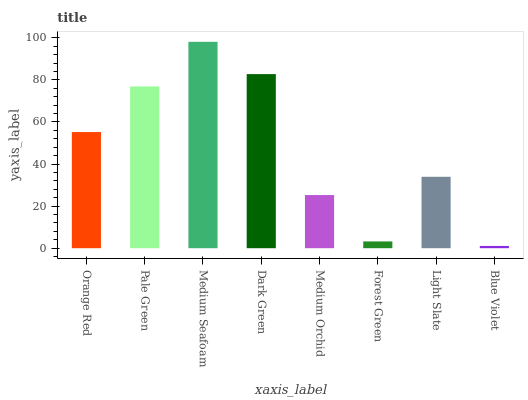Is Blue Violet the minimum?
Answer yes or no. Yes. Is Medium Seafoam the maximum?
Answer yes or no. Yes. Is Pale Green the minimum?
Answer yes or no. No. Is Pale Green the maximum?
Answer yes or no. No. Is Pale Green greater than Orange Red?
Answer yes or no. Yes. Is Orange Red less than Pale Green?
Answer yes or no. Yes. Is Orange Red greater than Pale Green?
Answer yes or no. No. Is Pale Green less than Orange Red?
Answer yes or no. No. Is Orange Red the high median?
Answer yes or no. Yes. Is Light Slate the low median?
Answer yes or no. Yes. Is Light Slate the high median?
Answer yes or no. No. Is Forest Green the low median?
Answer yes or no. No. 